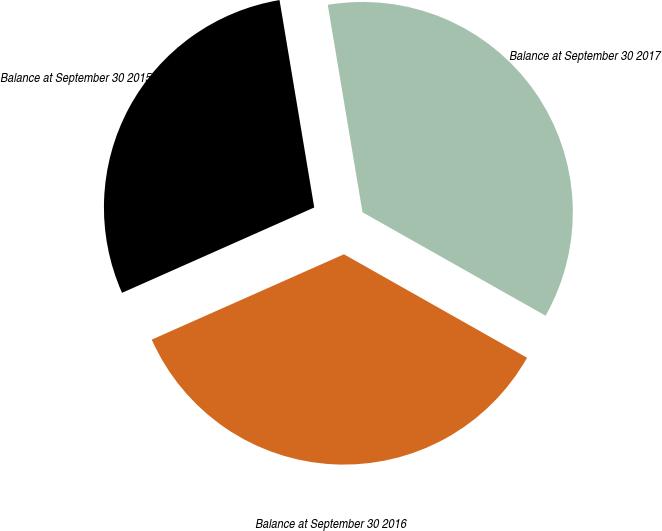Convert chart. <chart><loc_0><loc_0><loc_500><loc_500><pie_chart><fcel>Balance at September 30 2015<fcel>Balance at September 30 2016<fcel>Balance at September 30 2017<nl><fcel>29.01%<fcel>35.16%<fcel>35.82%<nl></chart> 